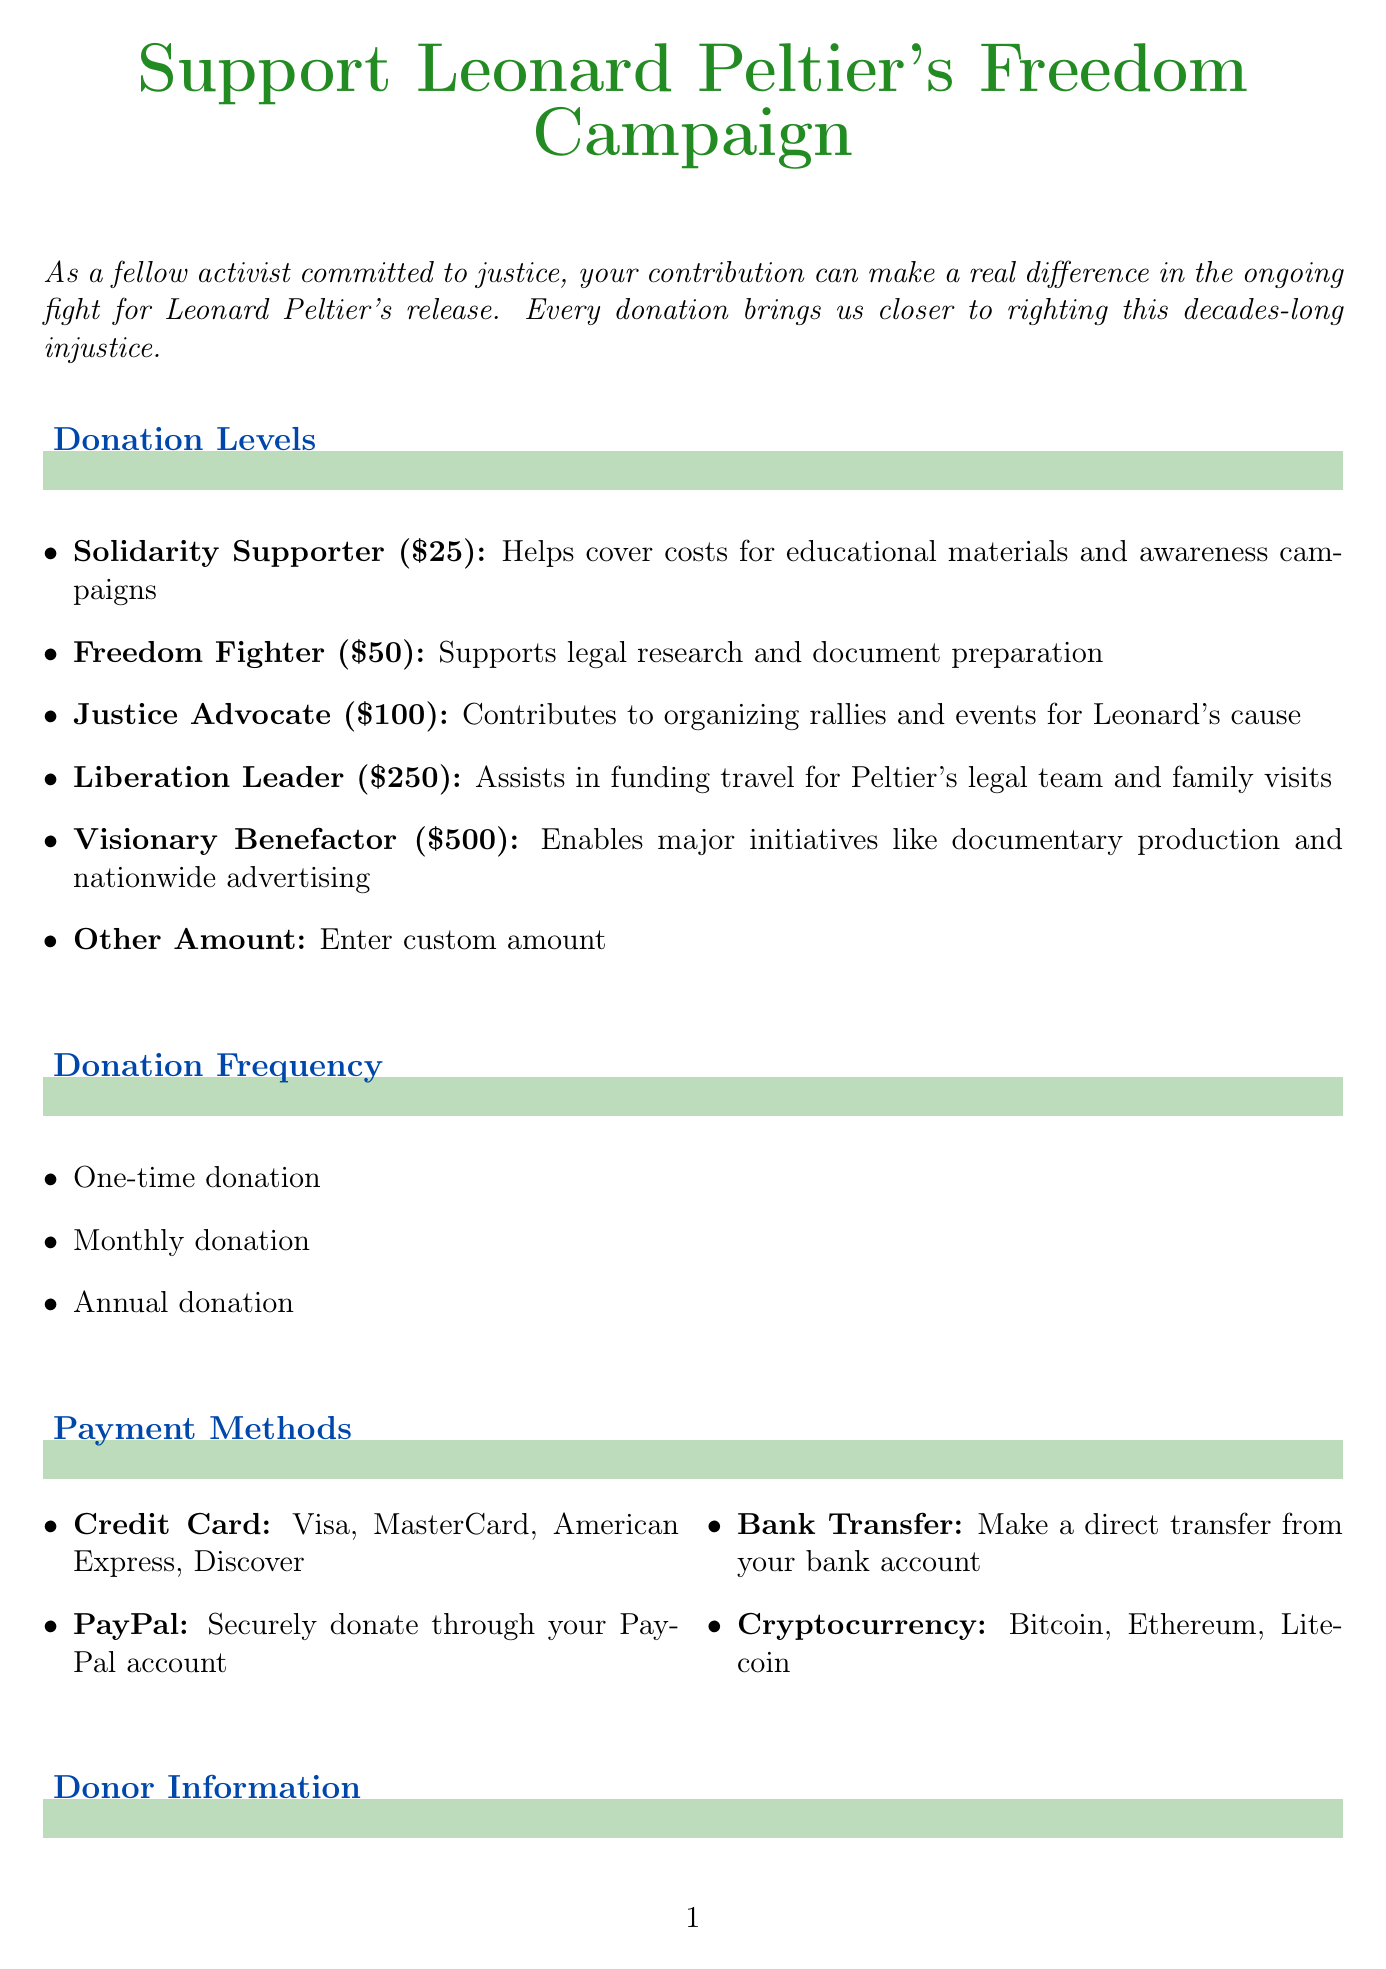what is the title of the form? The title of the form is the main heading, located at the top.
Answer: Support Leonard Peltier's Freedom Campaign what is the minimum donation amount? The minimum donation level is listed as the first option in the donation levels section.
Answer: 25 what is the purpose of the Visionary Benefactor donation level? The description specifies what initiatives this donation level supports.
Answer: Enables major initiatives like documentary production and nationwide advertising how many payment methods are available? The number of payment methods can be counted from the payment methods section.
Answer: 4 what is one of the legal disclaimers associated with donations? The disclaimer outlines important information concerning the nature of donations.
Answer: Donations to the Leonard Peltier Defense Committee are not tax-deductible how can donors opt for a recurring donation? This is determined by checking the donation frequency options provided.
Answer: Monthly donation which organization is listed as related? The related organizations are in a list format, any name can be given.
Answer: Amnesty International what contact method can be used for inquiries? This is found in the contact information section, specifying how to reach out.
Answer: Email what is the amount for the Liberation Leader donation level? This can be found in the list of donation levels, specifically the amount assigned to that level.
Answer: 250 